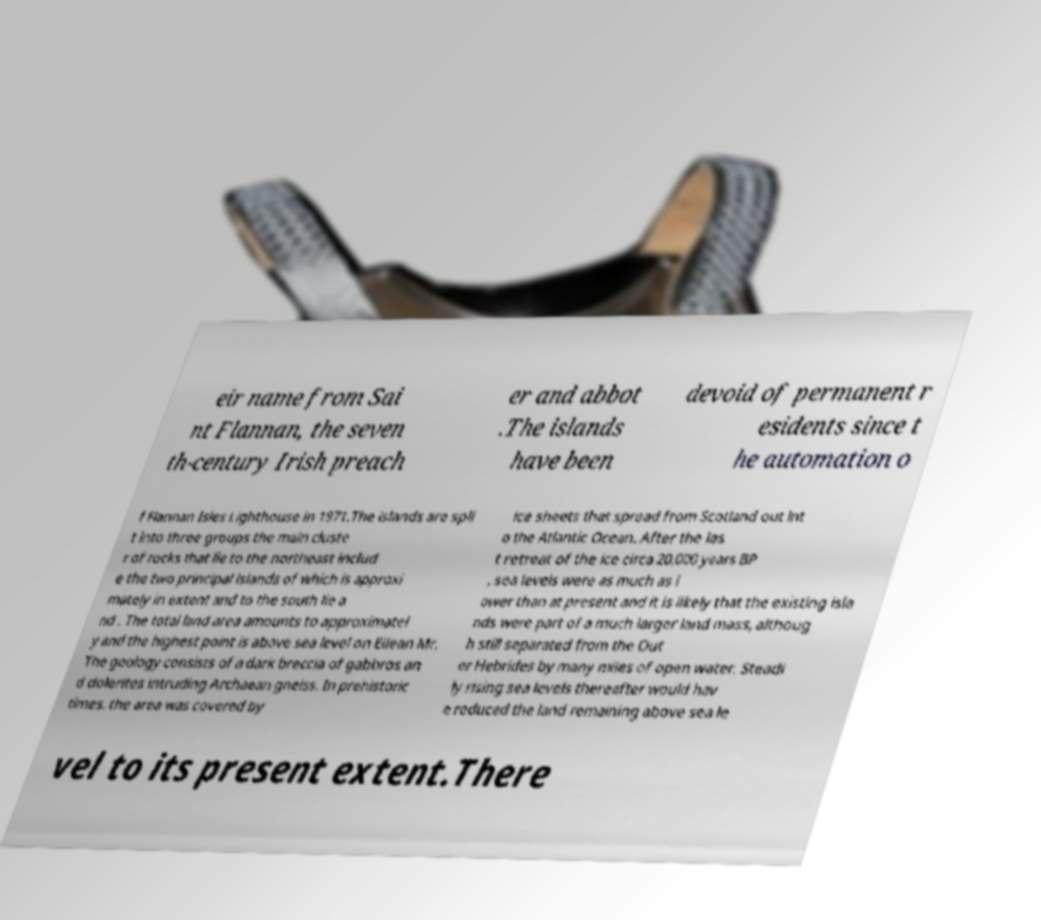Could you assist in decoding the text presented in this image and type it out clearly? eir name from Sai nt Flannan, the seven th-century Irish preach er and abbot .The islands have been devoid of permanent r esidents since t he automation o f Flannan Isles Lighthouse in 1971.The islands are spli t into three groups the main cluste r of rocks that lie to the northeast includ e the two principal islands of which is approxi mately in extent and to the south lie a nd . The total land area amounts to approximatel y and the highest point is above sea level on Eilean Mr. The geology consists of a dark breccia of gabbros an d dolerites intruding Archaean gneiss. In prehistoric times, the area was covered by ice sheets that spread from Scotland out int o the Atlantic Ocean. After the las t retreat of the ice circa 20,000 years BP , sea levels were as much as l ower than at present and it is likely that the existing isla nds were part of a much larger land mass, althoug h still separated from the Out er Hebrides by many miles of open water. Steadi ly rising sea levels thereafter would hav e reduced the land remaining above sea le vel to its present extent.There 